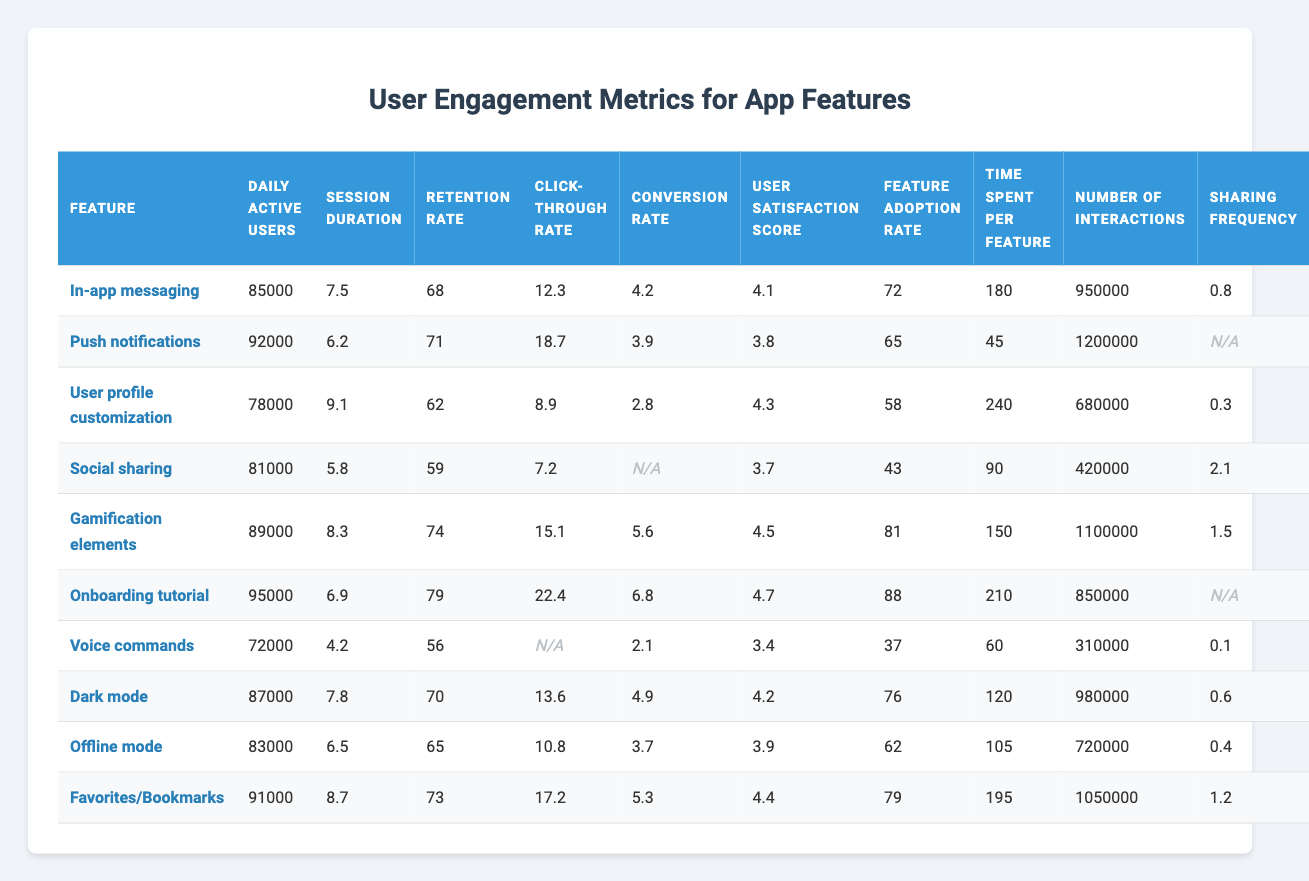What is the highest daily active users count among the features? Looking through the "Daily active users" column, the highest count is 95,000 associated with the "Onboarding tutorial" feature.
Answer: 95000 Which feature has the longest average session duration? Checking the "Session duration" column, the feature with the longest session duration is "User profile customization" at 9.1 minutes.
Answer: 9.1 Is the feature "Voice commands" associated with a higher retention rate than "Social sharing"? Comparing the "Retention rate" values, "Voice commands" has a retention rate of 56, whereas "Social sharing" has a rate of 59, so "Voice commands" does not have a higher retention rate.
Answer: No Which feature shows the highest conversion rate among the listed features? In the "Conversion rate" column, the highest value is 6.8, which corresponds to the "Onboarding tutorial" feature.
Answer: 6.8 What is the average user satisfaction score across all features? Adding the user satisfaction scores (4.1, 3.8, 4.3, 3.7, 4.5, 4.7, 3.4, 4.2, 3.9, 4.4) and dividing by 10 gives an average of 4.17.
Answer: 4.17 Does the feature "Dark mode" have more interactions than "Favorites/Bookmarks"? "Dark mode" has 120 interactions, while "Favorites/Bookmarks" has 950,000 interactions, indicating that "Dark mode" has fewer interactions.
Answer: No Which feature has the lowest click-through rate, and what is that rate? Checking the "Click-through rate" column, the feature "User profile customization" has the lowest click-through rate of 8.9.
Answer: 8.9 What is the sum of the feature adoption rates for "In-app messaging" and "Push notifications"? Adding the feature adoption rates for these features (72 + 65) totals to 137.
Answer: 137 Which feature shows the best retention rate, and what is it? The "Onboarding tutorial" feature has the best retention rate of 79. Looking at the "Retention rate" column, this is the highest value.
Answer: 79 Identify the feature with the highest sharing frequency. From the "Sharing frequency" column, the "Social sharing" feature stands out with a frequency of 2.1, which is the highest.
Answer: 2.1 